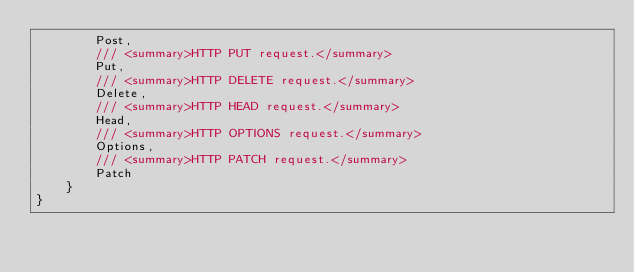Convert code to text. <code><loc_0><loc_0><loc_500><loc_500><_C#_>        Post,
        /// <summary>HTTP PUT request.</summary>
        Put,
        /// <summary>HTTP DELETE request.</summary>
        Delete,
        /// <summary>HTTP HEAD request.</summary>
        Head,
        /// <summary>HTTP OPTIONS request.</summary>
        Options,
        /// <summary>HTTP PATCH request.</summary>
        Patch
    }
}
</code> 